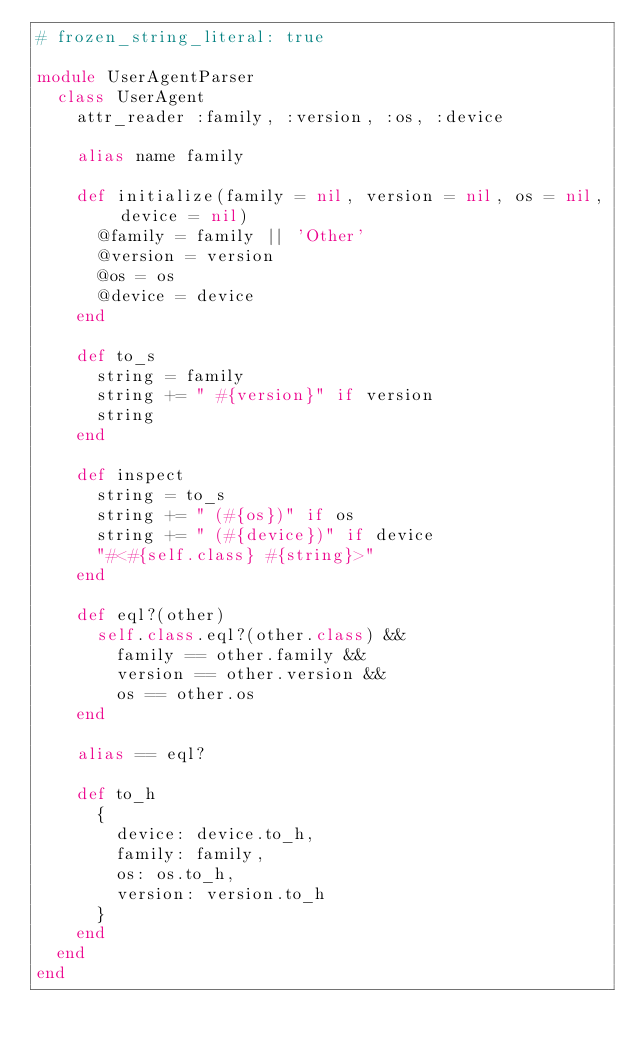Convert code to text. <code><loc_0><loc_0><loc_500><loc_500><_Ruby_># frozen_string_literal: true

module UserAgentParser
  class UserAgent
    attr_reader :family, :version, :os, :device

    alias name family

    def initialize(family = nil, version = nil, os = nil, device = nil)
      @family = family || 'Other'
      @version = version
      @os = os
      @device = device
    end

    def to_s
      string = family
      string += " #{version}" if version
      string
    end

    def inspect
      string = to_s
      string += " (#{os})" if os
      string += " (#{device})" if device
      "#<#{self.class} #{string}>"
    end

    def eql?(other)
      self.class.eql?(other.class) &&
        family == other.family &&
        version == other.version &&
        os == other.os
    end

    alias == eql?

    def to_h
      {
        device: device.to_h,
        family: family,
        os: os.to_h,
        version: version.to_h
      }
    end
  end
end
</code> 